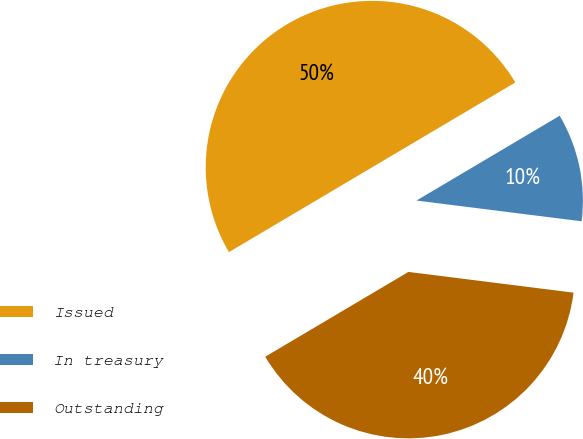Convert chart. <chart><loc_0><loc_0><loc_500><loc_500><pie_chart><fcel>Issued<fcel>In treasury<fcel>Outstanding<nl><fcel>50.0%<fcel>10.5%<fcel>39.5%<nl></chart> 